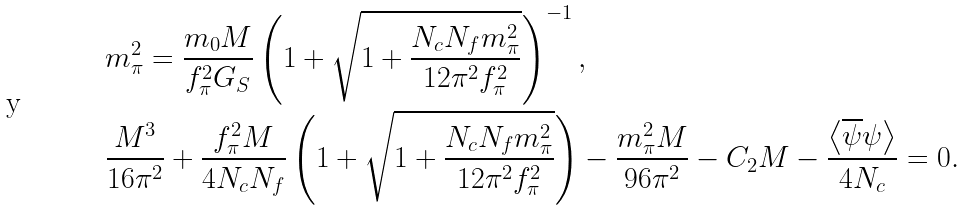<formula> <loc_0><loc_0><loc_500><loc_500>& m _ { \pi } ^ { 2 } = \frac { m _ { 0 } M } { f _ { \pi } ^ { 2 } G _ { S } } \left ( 1 + \sqrt { 1 + \frac { N _ { c } N _ { f } m _ { \pi } ^ { 2 } } { 1 2 \pi ^ { 2 } f _ { \pi } ^ { 2 } } } \right ) ^ { - 1 } , \\ & \frac { M ^ { 3 } } { 1 6 \pi ^ { 2 } } + \frac { f _ { \pi } ^ { 2 } M } { 4 N _ { c } N _ { f } } \left ( 1 + \sqrt { 1 + \frac { N _ { c } N _ { f } m _ { \pi } ^ { 2 } } { 1 2 \pi ^ { 2 } f _ { \pi } ^ { 2 } } } \right ) - \frac { m _ { \pi } ^ { 2 } M } { 9 6 \pi ^ { 2 } } - C _ { 2 } M - \frac { \left \langle \overline { \psi } \psi \right \rangle } { 4 N _ { c } } = 0 .</formula> 